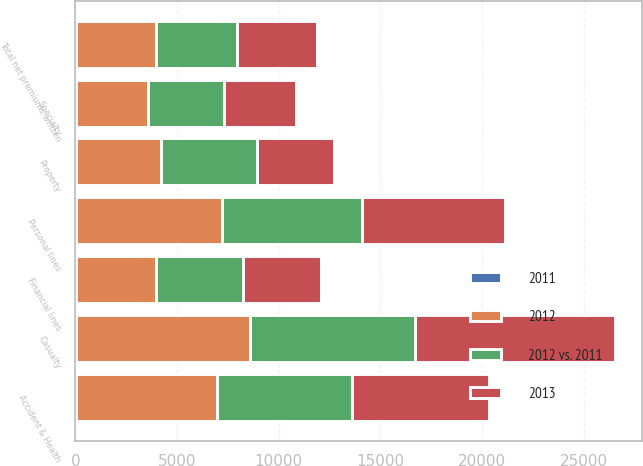Convert chart. <chart><loc_0><loc_0><loc_500><loc_500><stacked_bar_chart><ecel><fcel>Casualty<fcel>Property<fcel>Specialty<fcel>Financial lines<fcel>Total net premiums written<fcel>Accident & Health<fcel>Personal lines<nl><fcel>2012 vs. 2011<fcel>8145<fcel>4708<fcel>3730<fcel>4259<fcel>3959<fcel>6621<fcel>6931<nl><fcel>2012<fcel>8574<fcel>4191<fcel>3576<fcel>3959<fcel>3959<fcel>6969<fcel>7181<nl><fcel>2013<fcel>9820<fcel>3811<fcel>3552<fcel>3872<fcel>3959<fcel>6762<fcel>7000<nl><fcel>2011<fcel>5<fcel>12<fcel>4<fcel>8<fcel>3<fcel>5<fcel>3<nl></chart> 